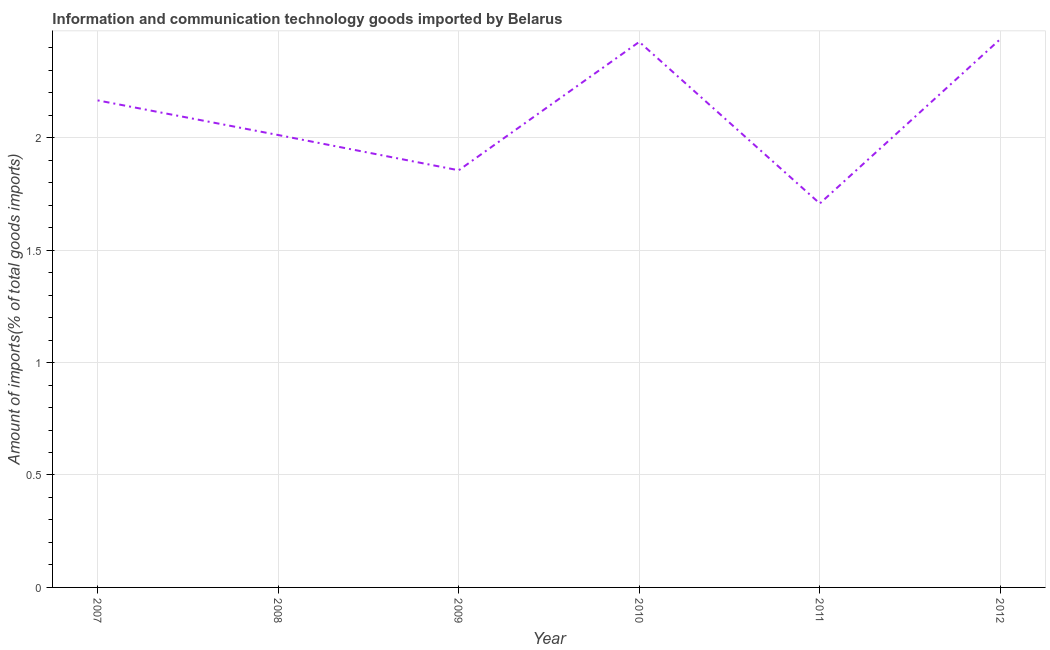What is the amount of ict goods imports in 2011?
Keep it short and to the point. 1.71. Across all years, what is the maximum amount of ict goods imports?
Provide a succinct answer. 2.44. Across all years, what is the minimum amount of ict goods imports?
Your answer should be very brief. 1.71. In which year was the amount of ict goods imports minimum?
Give a very brief answer. 2011. What is the sum of the amount of ict goods imports?
Provide a short and direct response. 12.6. What is the difference between the amount of ict goods imports in 2008 and 2011?
Provide a short and direct response. 0.3. What is the average amount of ict goods imports per year?
Ensure brevity in your answer.  2.1. What is the median amount of ict goods imports?
Give a very brief answer. 2.09. In how many years, is the amount of ict goods imports greater than 1.1 %?
Your answer should be very brief. 6. What is the ratio of the amount of ict goods imports in 2008 to that in 2012?
Keep it short and to the point. 0.82. Is the amount of ict goods imports in 2007 less than that in 2009?
Offer a very short reply. No. Is the difference between the amount of ict goods imports in 2007 and 2009 greater than the difference between any two years?
Ensure brevity in your answer.  No. What is the difference between the highest and the second highest amount of ict goods imports?
Make the answer very short. 0.01. What is the difference between the highest and the lowest amount of ict goods imports?
Ensure brevity in your answer.  0.73. Does the amount of ict goods imports monotonically increase over the years?
Give a very brief answer. No. How many lines are there?
Offer a terse response. 1. How many years are there in the graph?
Make the answer very short. 6. Does the graph contain any zero values?
Offer a terse response. No. Does the graph contain grids?
Make the answer very short. Yes. What is the title of the graph?
Keep it short and to the point. Information and communication technology goods imported by Belarus. What is the label or title of the X-axis?
Your answer should be very brief. Year. What is the label or title of the Y-axis?
Offer a terse response. Amount of imports(% of total goods imports). What is the Amount of imports(% of total goods imports) in 2007?
Provide a succinct answer. 2.17. What is the Amount of imports(% of total goods imports) in 2008?
Your answer should be compact. 2.01. What is the Amount of imports(% of total goods imports) of 2009?
Give a very brief answer. 1.85. What is the Amount of imports(% of total goods imports) in 2010?
Your response must be concise. 2.43. What is the Amount of imports(% of total goods imports) in 2011?
Provide a succinct answer. 1.71. What is the Amount of imports(% of total goods imports) of 2012?
Your response must be concise. 2.44. What is the difference between the Amount of imports(% of total goods imports) in 2007 and 2008?
Make the answer very short. 0.15. What is the difference between the Amount of imports(% of total goods imports) in 2007 and 2009?
Offer a very short reply. 0.31. What is the difference between the Amount of imports(% of total goods imports) in 2007 and 2010?
Offer a terse response. -0.26. What is the difference between the Amount of imports(% of total goods imports) in 2007 and 2011?
Offer a very short reply. 0.46. What is the difference between the Amount of imports(% of total goods imports) in 2007 and 2012?
Provide a succinct answer. -0.27. What is the difference between the Amount of imports(% of total goods imports) in 2008 and 2009?
Make the answer very short. 0.16. What is the difference between the Amount of imports(% of total goods imports) in 2008 and 2010?
Offer a terse response. -0.41. What is the difference between the Amount of imports(% of total goods imports) in 2008 and 2011?
Offer a terse response. 0.3. What is the difference between the Amount of imports(% of total goods imports) in 2008 and 2012?
Make the answer very short. -0.43. What is the difference between the Amount of imports(% of total goods imports) in 2009 and 2010?
Ensure brevity in your answer.  -0.57. What is the difference between the Amount of imports(% of total goods imports) in 2009 and 2011?
Make the answer very short. 0.15. What is the difference between the Amount of imports(% of total goods imports) in 2009 and 2012?
Your answer should be very brief. -0.58. What is the difference between the Amount of imports(% of total goods imports) in 2010 and 2011?
Give a very brief answer. 0.72. What is the difference between the Amount of imports(% of total goods imports) in 2010 and 2012?
Your answer should be very brief. -0.01. What is the difference between the Amount of imports(% of total goods imports) in 2011 and 2012?
Give a very brief answer. -0.73. What is the ratio of the Amount of imports(% of total goods imports) in 2007 to that in 2008?
Your response must be concise. 1.08. What is the ratio of the Amount of imports(% of total goods imports) in 2007 to that in 2009?
Ensure brevity in your answer.  1.17. What is the ratio of the Amount of imports(% of total goods imports) in 2007 to that in 2010?
Provide a short and direct response. 0.89. What is the ratio of the Amount of imports(% of total goods imports) in 2007 to that in 2011?
Your answer should be very brief. 1.27. What is the ratio of the Amount of imports(% of total goods imports) in 2007 to that in 2012?
Give a very brief answer. 0.89. What is the ratio of the Amount of imports(% of total goods imports) in 2008 to that in 2009?
Give a very brief answer. 1.08. What is the ratio of the Amount of imports(% of total goods imports) in 2008 to that in 2010?
Offer a terse response. 0.83. What is the ratio of the Amount of imports(% of total goods imports) in 2008 to that in 2011?
Offer a very short reply. 1.18. What is the ratio of the Amount of imports(% of total goods imports) in 2008 to that in 2012?
Your response must be concise. 0.82. What is the ratio of the Amount of imports(% of total goods imports) in 2009 to that in 2010?
Your answer should be very brief. 0.77. What is the ratio of the Amount of imports(% of total goods imports) in 2009 to that in 2011?
Your answer should be compact. 1.09. What is the ratio of the Amount of imports(% of total goods imports) in 2009 to that in 2012?
Give a very brief answer. 0.76. What is the ratio of the Amount of imports(% of total goods imports) in 2010 to that in 2011?
Ensure brevity in your answer.  1.42. What is the ratio of the Amount of imports(% of total goods imports) in 2011 to that in 2012?
Your answer should be very brief. 0.7. 